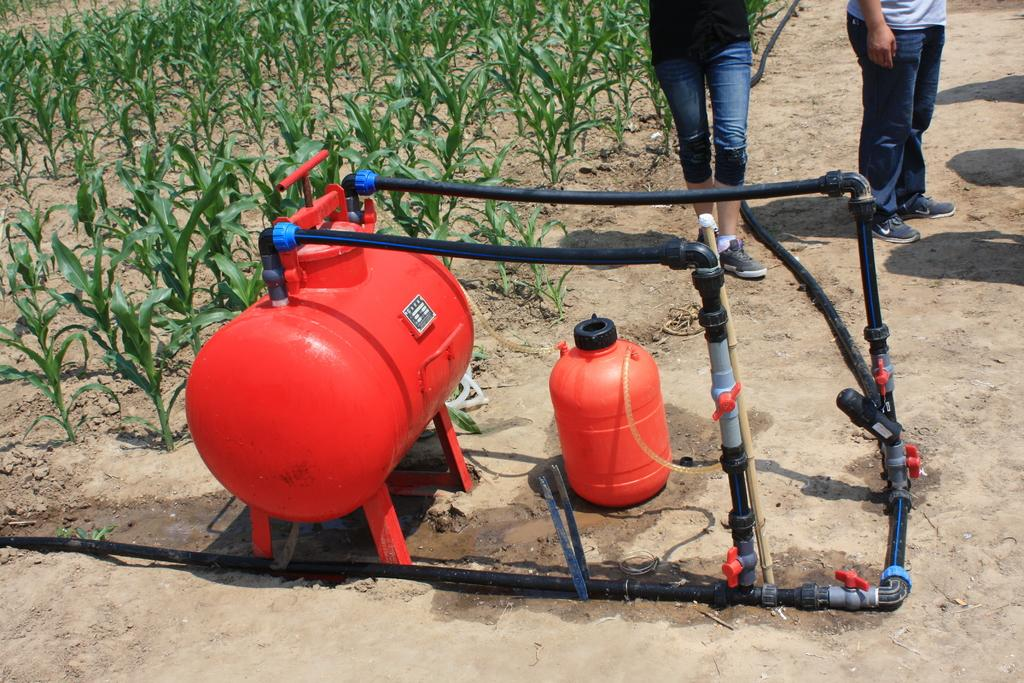What is located in the middle of the image? There are plants and a machine in the middle of the image. What can be seen near the plants and the machine? There are two persons at the top of the image. What type of zephyr can be seen blowing through the plants in the image? There is no zephyr present in the image, and therefore no such activity can be observed. 